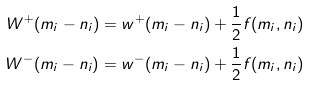<formula> <loc_0><loc_0><loc_500><loc_500>W ^ { + } ( m _ { i } - n _ { i } ) = w ^ { + } ( m _ { i } - n _ { i } ) + \frac { 1 } { 2 } f ( m _ { i } , n _ { i } ) \\ W ^ { - } ( m _ { i } - n _ { i } ) = w ^ { - } ( m _ { i } - n _ { i } ) + \frac { 1 } { 2 } f ( m _ { i } , n _ { i } )</formula> 